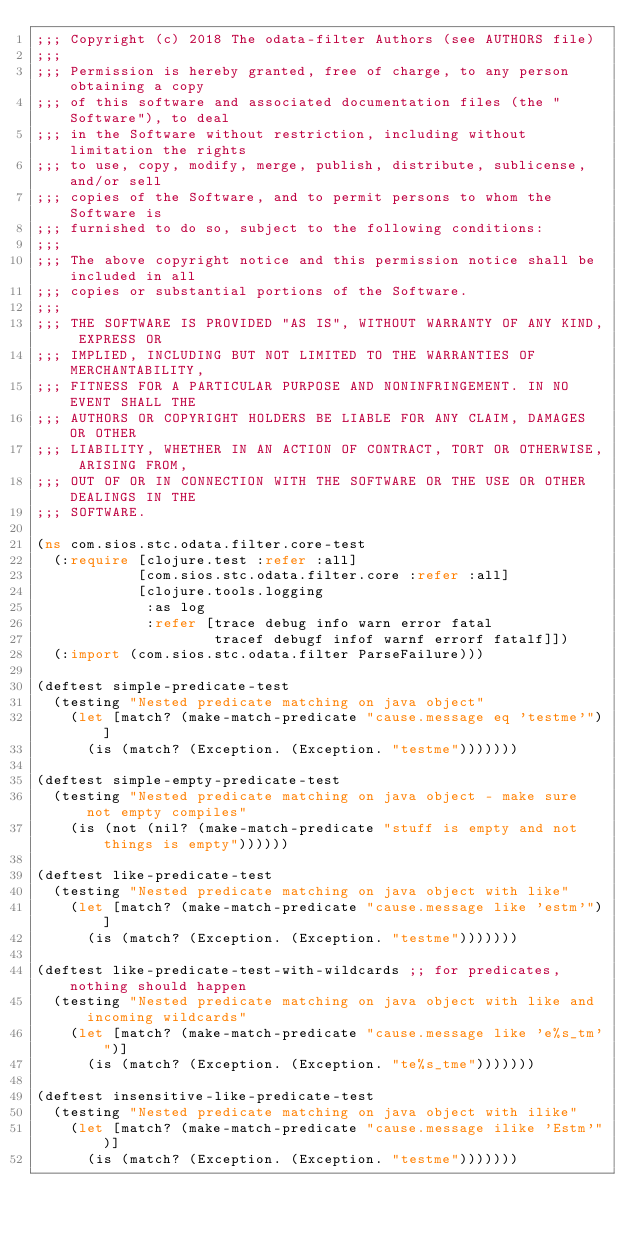Convert code to text. <code><loc_0><loc_0><loc_500><loc_500><_Clojure_>;;; Copyright (c) 2018 The odata-filter Authors (see AUTHORS file)
;;;
;;; Permission is hereby granted, free of charge, to any person obtaining a copy
;;; of this software and associated documentation files (the "Software"), to deal
;;; in the Software without restriction, including without limitation the rights
;;; to use, copy, modify, merge, publish, distribute, sublicense, and/or sell
;;; copies of the Software, and to permit persons to whom the Software is
;;; furnished to do so, subject to the following conditions:
;;;
;;; The above copyright notice and this permission notice shall be included in all
;;; copies or substantial portions of the Software.
;;;
;;; THE SOFTWARE IS PROVIDED "AS IS", WITHOUT WARRANTY OF ANY KIND, EXPRESS OR
;;; IMPLIED, INCLUDING BUT NOT LIMITED TO THE WARRANTIES OF MERCHANTABILITY,
;;; FITNESS FOR A PARTICULAR PURPOSE AND NONINFRINGEMENT. IN NO EVENT SHALL THE
;;; AUTHORS OR COPYRIGHT HOLDERS BE LIABLE FOR ANY CLAIM, DAMAGES OR OTHER
;;; LIABILITY, WHETHER IN AN ACTION OF CONTRACT, TORT OR OTHERWISE, ARISING FROM,
;;; OUT OF OR IN CONNECTION WITH THE SOFTWARE OR THE USE OR OTHER DEALINGS IN THE
;;; SOFTWARE.

(ns com.sios.stc.odata.filter.core-test
  (:require [clojure.test :refer :all]
            [com.sios.stc.odata.filter.core :refer :all]
            [clojure.tools.logging
             :as log
             :refer [trace debug info warn error fatal
                     tracef debugf infof warnf errorf fatalf]])
  (:import (com.sios.stc.odata.filter ParseFailure)))

(deftest simple-predicate-test
  (testing "Nested predicate matching on java object"
    (let [match? (make-match-predicate "cause.message eq 'testme'")]
      (is (match? (Exception. (Exception. "testme")))))))

(deftest simple-empty-predicate-test
  (testing "Nested predicate matching on java object - make sure not empty compiles"
    (is (not (nil? (make-match-predicate "stuff is empty and not things is empty"))))))

(deftest like-predicate-test
  (testing "Nested predicate matching on java object with like"
    (let [match? (make-match-predicate "cause.message like 'estm'")]
      (is (match? (Exception. (Exception. "testme")))))))

(deftest like-predicate-test-with-wildcards ;; for predicates, nothing should happen
  (testing "Nested predicate matching on java object with like and incoming wildcards"
    (let [match? (make-match-predicate "cause.message like 'e%s_tm'")]
      (is (match? (Exception. (Exception. "te%s_tme")))))))

(deftest insensitive-like-predicate-test
  (testing "Nested predicate matching on java object with ilike"
    (let [match? (make-match-predicate "cause.message ilike 'Estm'")]
      (is (match? (Exception. (Exception. "testme")))))))
</code> 